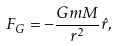<formula> <loc_0><loc_0><loc_500><loc_500>F _ { G } = - { \frac { G m M } { r ^ { 2 } } } { \hat { r } } ,</formula> 